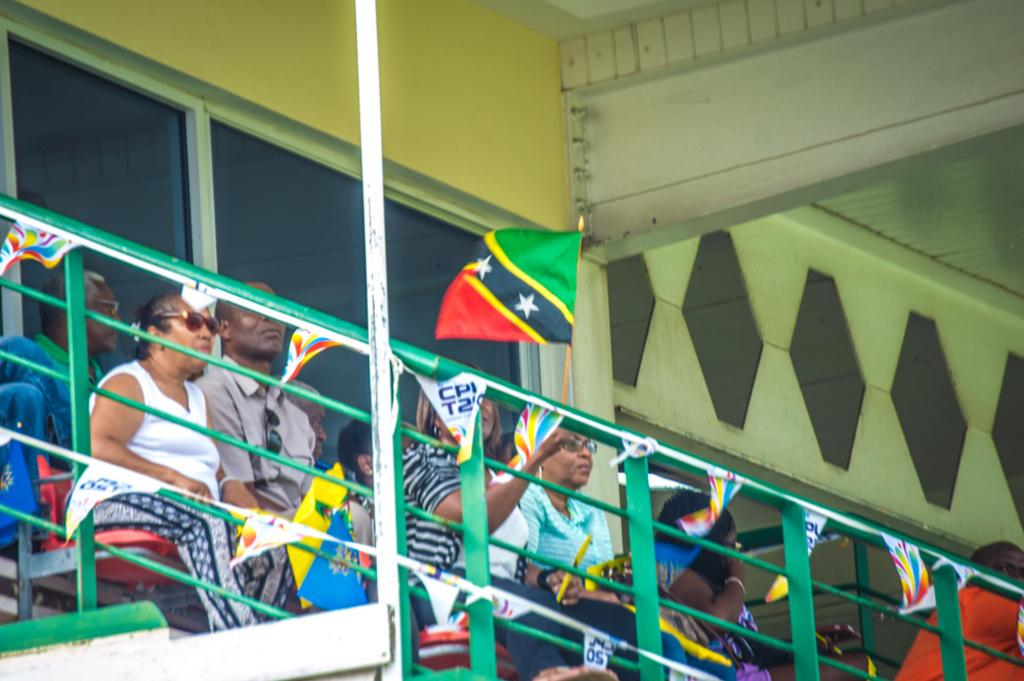<image>
Write a terse but informative summary of the picture. The small banner hanging from the railing says CPI on it. 